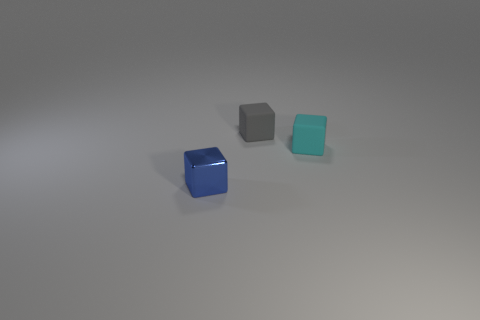Is there anything else that is the same material as the small blue object?
Provide a succinct answer. No. There is a small object that is behind the object that is on the right side of the gray rubber object; what is its color?
Provide a short and direct response. Gray. There is another cube that is the same material as the cyan cube; what is its size?
Make the answer very short. Small. There is a tiny rubber object to the left of the tiny rubber thing that is in front of the small gray rubber thing; is there a gray cube left of it?
Offer a terse response. No. What number of metallic objects are the same size as the gray rubber cube?
Make the answer very short. 1. There is a small thing that is both to the right of the blue metallic cube and in front of the small gray block; what is its shape?
Your answer should be very brief. Cube. Are there any tiny cyan rubber cylinders?
Offer a terse response. No. What is the color of the small rubber block that is behind the tiny cyan cube?
Your answer should be very brief. Gray. Does the cyan cube have the same size as the rubber thing that is to the left of the tiny cyan cube?
Offer a terse response. Yes. What size is the thing that is both right of the tiny metallic thing and in front of the gray rubber cube?
Offer a terse response. Small. 